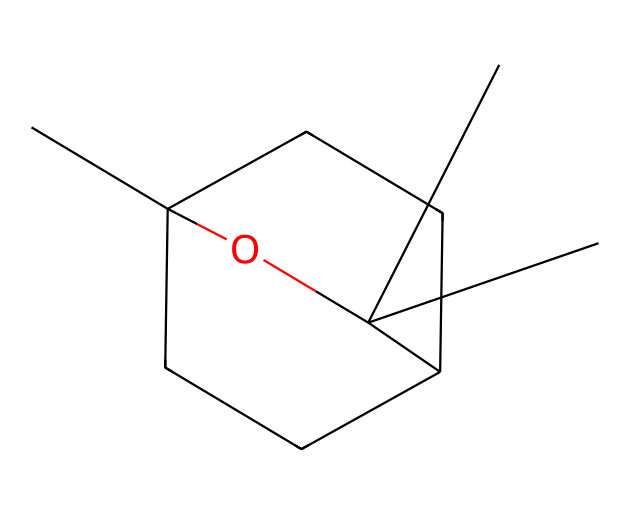What is the molecular formula of eucalyptol? To derive the molecular formula from the SMILES, count the number of each type of atom present. By examining the structure, there are 10 carbon atoms (C), 18 hydrogen atoms (H), and 1 oxygen atom (O). Therefore, the molecular formula is C10H18O.
Answer: C10H18O How many rings are present in eucalyptol? The visual structure allows us to identify the rings. When examining the connections of the carbon atoms, you can observe that there are two distinct ring structures present in the molecule.
Answer: 2 What type of compound is eucalyptol classified as? Eucalyptol is classified as a terpene, which is characterized by its natural occurrence in essential oils and aromatic compounds. Its structure, containing multiple isoprene units, aligns with the definition of terpenes.
Answer: terpene What characteristic functional group is present in eucalyptol? In reviewing the structure, we can find a hydroxyl (-OH) group attached to one of the carbon atoms, which is indicative of alcohols. This feature is crucial for its reactivity and solubility properties.
Answer: hydroxyl Which part of eucalyptol is responsible for its aromatic properties? The cyclical structure in eucalyptol is responsible for its aromatic properties. The presence of the ring system in the structure contributes to the overall volatility and fragrance typical of many terpenes, including eucalyptol.
Answer: ring structure 